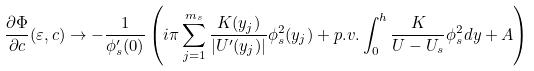<formula> <loc_0><loc_0><loc_500><loc_500>\frac { \partial \Phi } { \partial c } ( \varepsilon , c ) \rightarrow - \frac { 1 } { \phi _ { s } ^ { \prime } ( 0 ) } \left ( i \pi \sum _ { j = 1 } ^ { m _ { s } } \frac { K ( y _ { j } ) } { | U ^ { \prime } ( y _ { j } ) | } \phi _ { s } ^ { 2 } ( y _ { j } ) + p . v . \int _ { 0 } ^ { h } \frac { K } { U - U _ { s } } \phi _ { s } ^ { 2 } d y + A \right )</formula> 